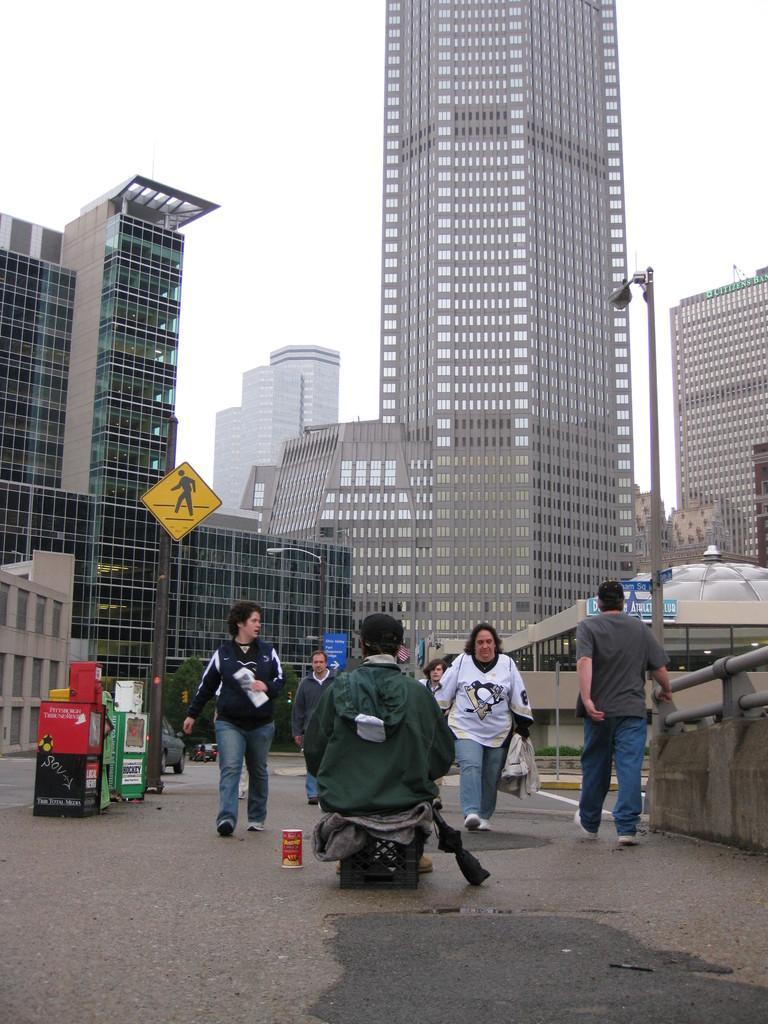Can you describe this image briefly? This image is taken outdoors. At the top of the image there is the sky. At the bottom of the image there is a road. In the background there are a few buildings and there is a skyscraper. There is a pole with a street light. There is a signboard and there are a few plants on the ground. There is a board with a text on it. On the left side of the image a car is moving on the road and there are a few objects on the road. On the right side of the image there is a board with a text on it. There is an architecture and there is a wall. There is a railing and a man is walking on the road. In the middle of the image a few are walking on the road. 